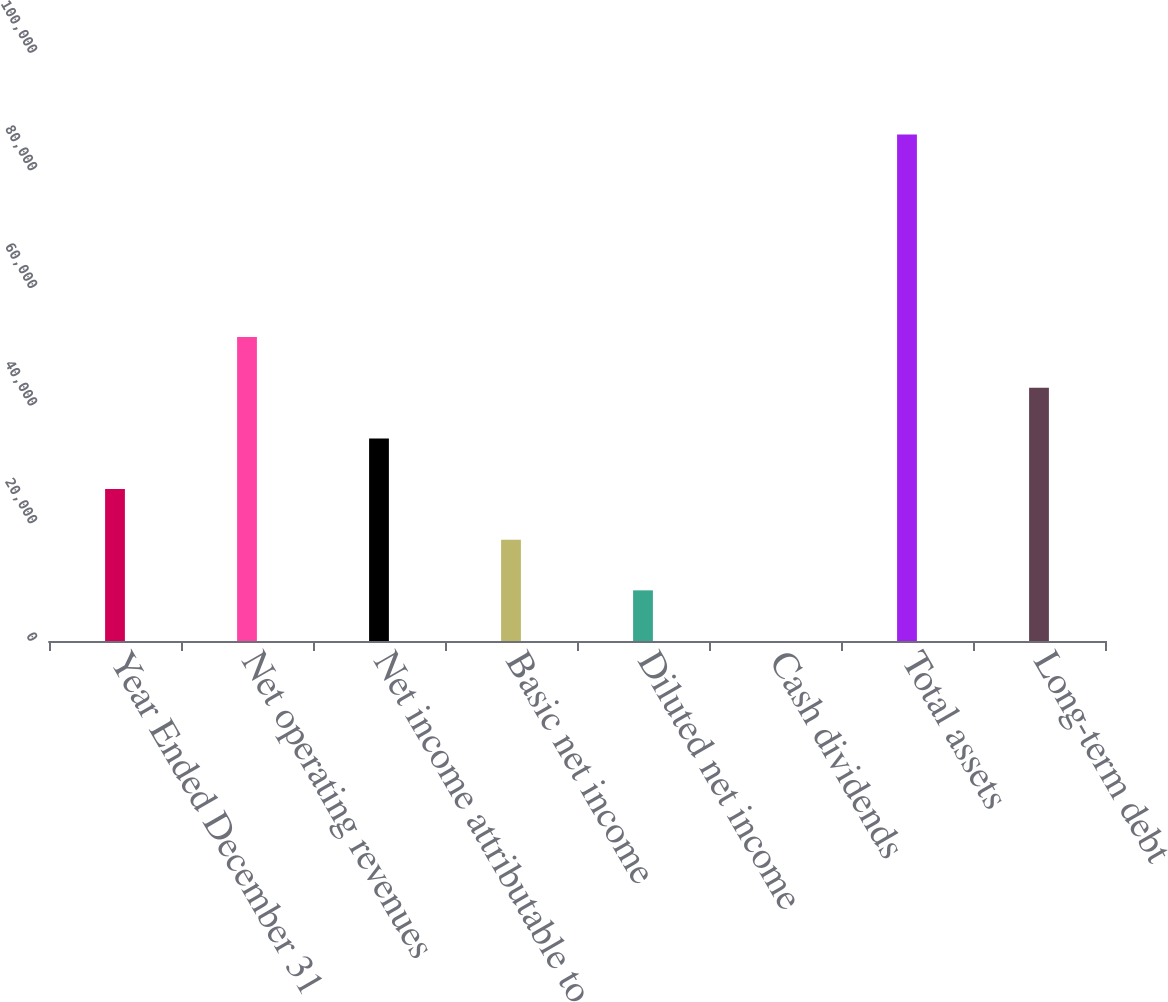<chart> <loc_0><loc_0><loc_500><loc_500><bar_chart><fcel>Year Ended December 31<fcel>Net operating revenues<fcel>Net income attributable to<fcel>Basic net income<fcel>Diluted net income<fcel>Cash dividends<fcel>Total assets<fcel>Long-term debt<nl><fcel>25843.6<fcel>51686.2<fcel>34457.8<fcel>17229.4<fcel>8615.22<fcel>1.02<fcel>86143<fcel>43072<nl></chart> 